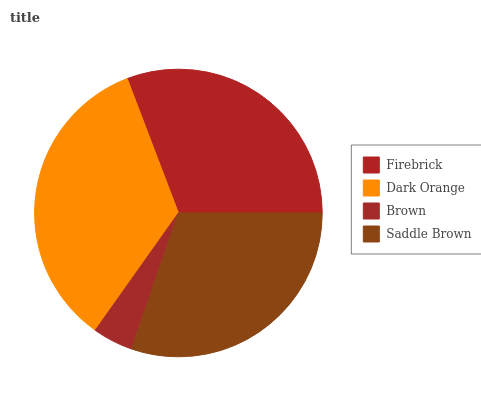Is Brown the minimum?
Answer yes or no. Yes. Is Dark Orange the maximum?
Answer yes or no. Yes. Is Dark Orange the minimum?
Answer yes or no. No. Is Brown the maximum?
Answer yes or no. No. Is Dark Orange greater than Brown?
Answer yes or no. Yes. Is Brown less than Dark Orange?
Answer yes or no. Yes. Is Brown greater than Dark Orange?
Answer yes or no. No. Is Dark Orange less than Brown?
Answer yes or no. No. Is Firebrick the high median?
Answer yes or no. Yes. Is Saddle Brown the low median?
Answer yes or no. Yes. Is Saddle Brown the high median?
Answer yes or no. No. Is Brown the low median?
Answer yes or no. No. 